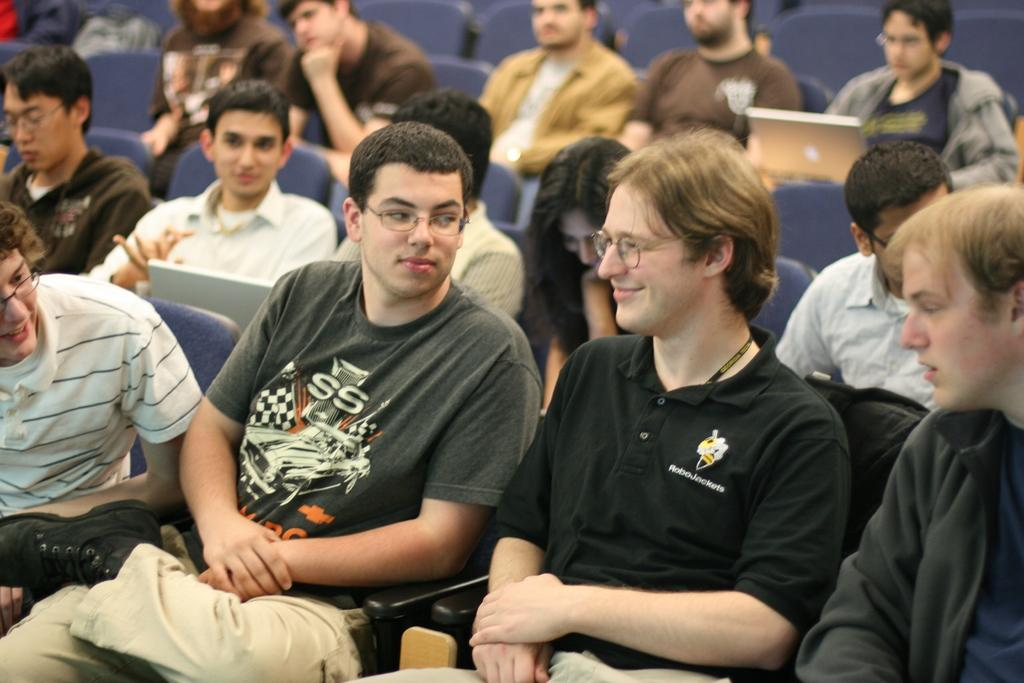What are the people in the image doing? The people in the image are sitting on chairs. What objects can be seen on the laps of the people? There are laptops in the image. What type of jellyfish can be seen swimming in the image? There are no jellyfish present in the image; it features people sitting on chairs with laptops. 